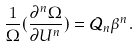Convert formula to latex. <formula><loc_0><loc_0><loc_500><loc_500>\frac { 1 } { \Omega } ( \frac { \partial ^ { n } \Omega } { \partial U ^ { n } } ) = { \mathcal { Q } } _ { n } \beta ^ { n } .</formula> 